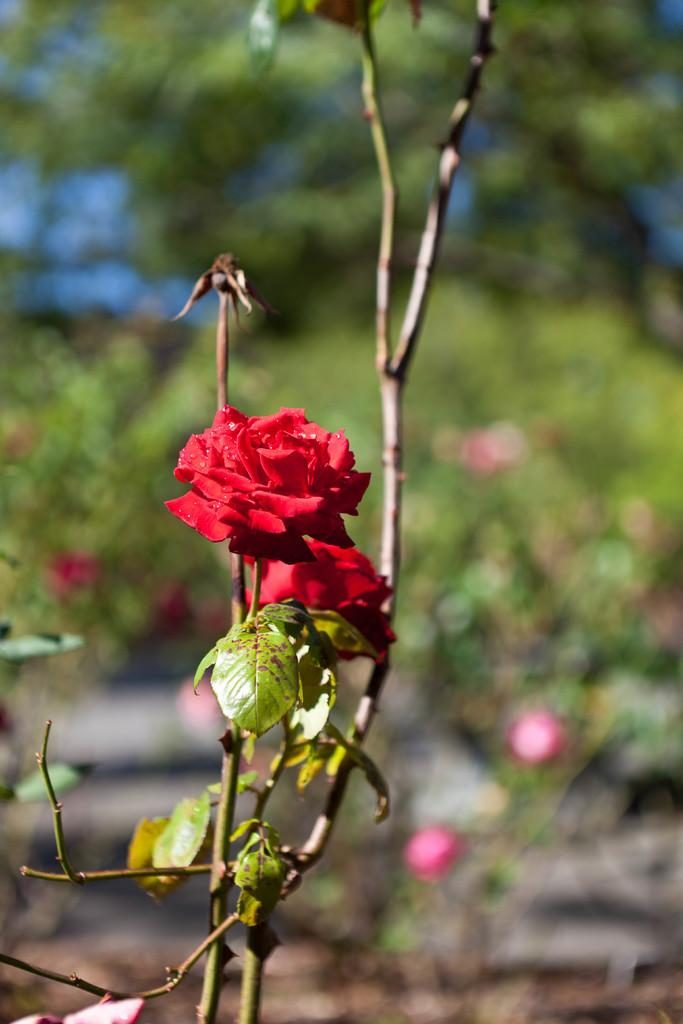What type of plant is in the image? There is a plant in the image, but the specific type cannot be determined from the provided facts. What can be seen in addition to the plant in the image? There are flowers in the image. How would you describe the background of the image? The background of the image is blurred. What type of vegetation is visible in the background? There is greenery visible in the background. What type of meat is being served on a plate in the image? There is no plate or meat present in the image; it features a plant, flowers, and a blurred background. 